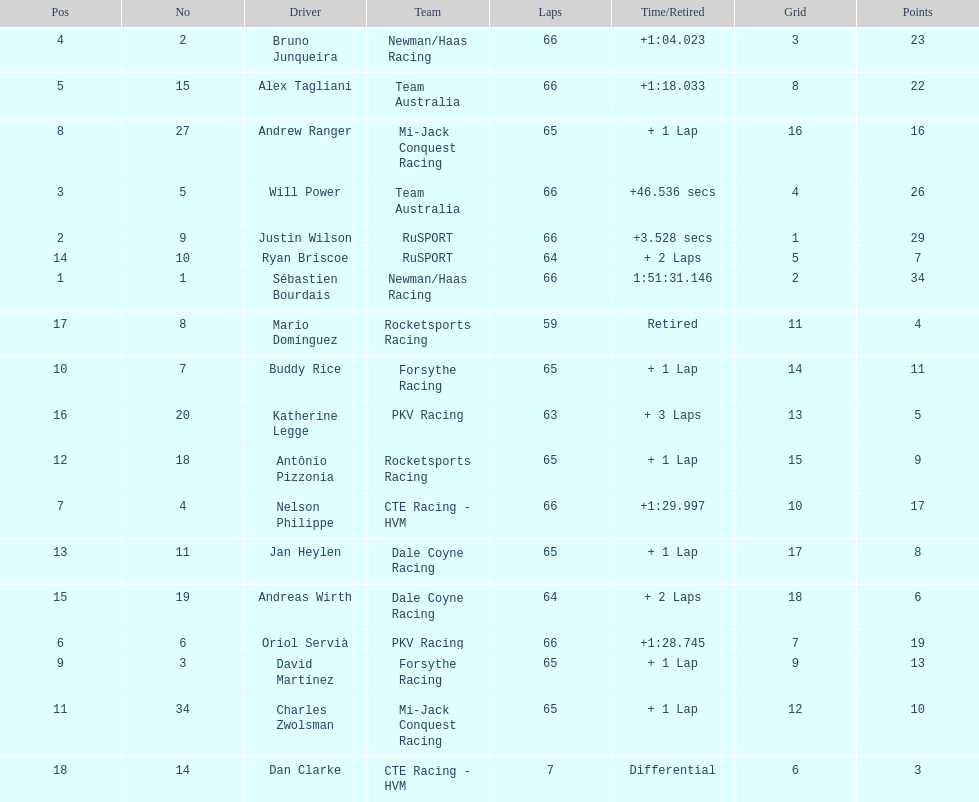How many drivers did not make more than 60 laps? 2. 